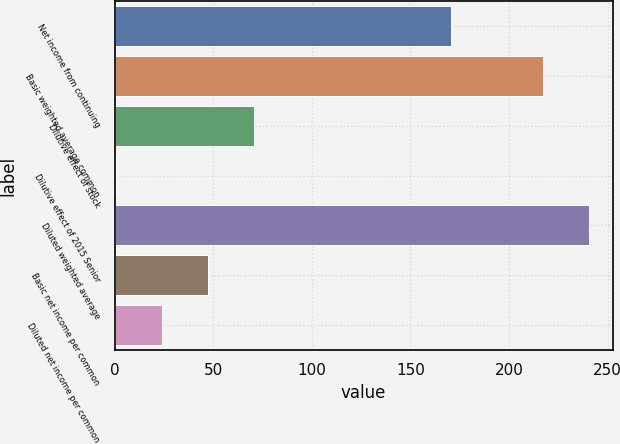Convert chart. <chart><loc_0><loc_0><loc_500><loc_500><bar_chart><fcel>Net income from continuing<fcel>Basic weighted average common<fcel>Dilutive effect of stock<fcel>Dilutive effect of 2015 Senior<fcel>Diluted weighted average<fcel>Basic net income per common<fcel>Diluted net income per common<nl><fcel>170.6<fcel>217.2<fcel>70.79<fcel>0.5<fcel>240.63<fcel>47.36<fcel>23.93<nl></chart> 